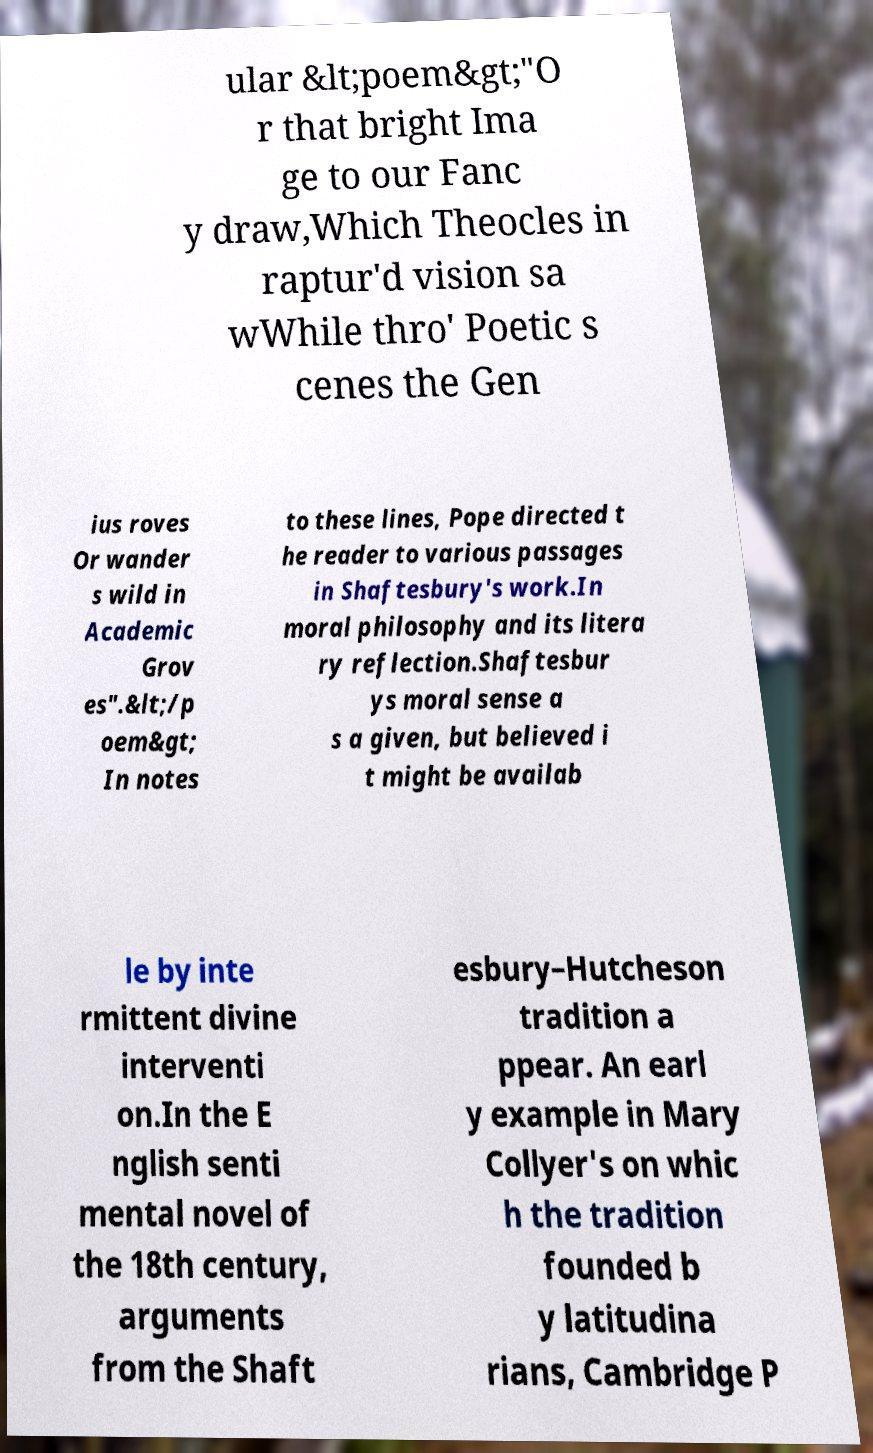Please identify and transcribe the text found in this image. ular &lt;poem&gt;"O r that bright Ima ge to our Fanc y draw,Which Theocles in raptur'd vision sa wWhile thro' Poetic s cenes the Gen ius roves Or wander s wild in Academic Grov es".&lt;/p oem&gt; In notes to these lines, Pope directed t he reader to various passages in Shaftesbury's work.In moral philosophy and its litera ry reflection.Shaftesbur ys moral sense a s a given, but believed i t might be availab le by inte rmittent divine interventi on.In the E nglish senti mental novel of the 18th century, arguments from the Shaft esbury–Hutcheson tradition a ppear. An earl y example in Mary Collyer's on whic h the tradition founded b y latitudina rians, Cambridge P 